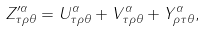Convert formula to latex. <formula><loc_0><loc_0><loc_500><loc_500>Z ^ { \prime \alpha } _ { \tau \rho \theta } = U ^ { \alpha } _ { \tau \rho \theta } + V ^ { \alpha } _ { \tau \rho \theta } + Y ^ { \alpha } _ { \rho \tau \theta } ,</formula> 